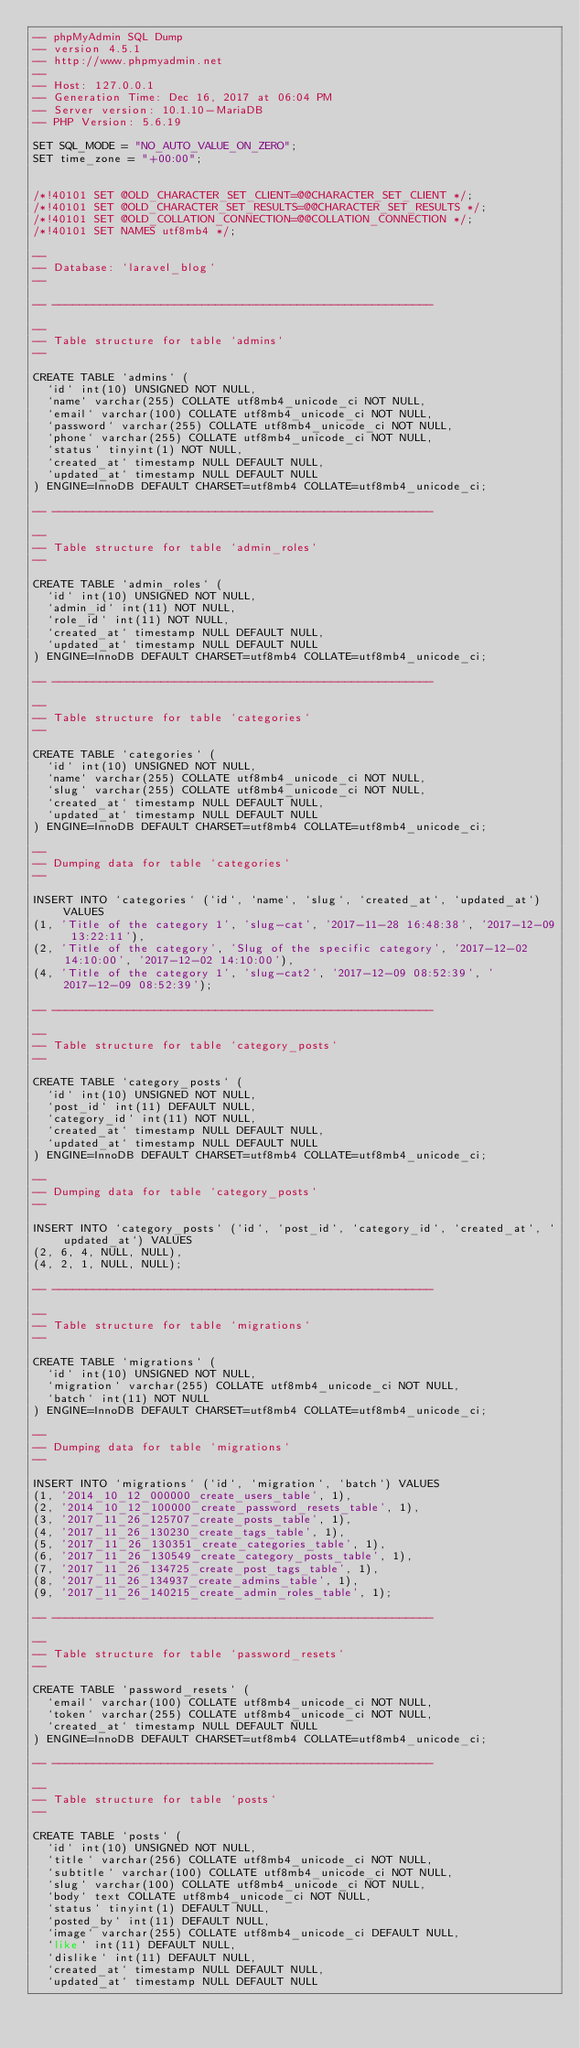<code> <loc_0><loc_0><loc_500><loc_500><_SQL_>-- phpMyAdmin SQL Dump
-- version 4.5.1
-- http://www.phpmyadmin.net
--
-- Host: 127.0.0.1
-- Generation Time: Dec 16, 2017 at 06:04 PM
-- Server version: 10.1.10-MariaDB
-- PHP Version: 5.6.19

SET SQL_MODE = "NO_AUTO_VALUE_ON_ZERO";
SET time_zone = "+00:00";


/*!40101 SET @OLD_CHARACTER_SET_CLIENT=@@CHARACTER_SET_CLIENT */;
/*!40101 SET @OLD_CHARACTER_SET_RESULTS=@@CHARACTER_SET_RESULTS */;
/*!40101 SET @OLD_COLLATION_CONNECTION=@@COLLATION_CONNECTION */;
/*!40101 SET NAMES utf8mb4 */;

--
-- Database: `laravel_blog`
--

-- --------------------------------------------------------

--
-- Table structure for table `admins`
--

CREATE TABLE `admins` (
  `id` int(10) UNSIGNED NOT NULL,
  `name` varchar(255) COLLATE utf8mb4_unicode_ci NOT NULL,
  `email` varchar(100) COLLATE utf8mb4_unicode_ci NOT NULL,
  `password` varchar(255) COLLATE utf8mb4_unicode_ci NOT NULL,
  `phone` varchar(255) COLLATE utf8mb4_unicode_ci NOT NULL,
  `status` tinyint(1) NOT NULL,
  `created_at` timestamp NULL DEFAULT NULL,
  `updated_at` timestamp NULL DEFAULT NULL
) ENGINE=InnoDB DEFAULT CHARSET=utf8mb4 COLLATE=utf8mb4_unicode_ci;

-- --------------------------------------------------------

--
-- Table structure for table `admin_roles`
--

CREATE TABLE `admin_roles` (
  `id` int(10) UNSIGNED NOT NULL,
  `admin_id` int(11) NOT NULL,
  `role_id` int(11) NOT NULL,
  `created_at` timestamp NULL DEFAULT NULL,
  `updated_at` timestamp NULL DEFAULT NULL
) ENGINE=InnoDB DEFAULT CHARSET=utf8mb4 COLLATE=utf8mb4_unicode_ci;

-- --------------------------------------------------------

--
-- Table structure for table `categories`
--

CREATE TABLE `categories` (
  `id` int(10) UNSIGNED NOT NULL,
  `name` varchar(255) COLLATE utf8mb4_unicode_ci NOT NULL,
  `slug` varchar(255) COLLATE utf8mb4_unicode_ci NOT NULL,
  `created_at` timestamp NULL DEFAULT NULL,
  `updated_at` timestamp NULL DEFAULT NULL
) ENGINE=InnoDB DEFAULT CHARSET=utf8mb4 COLLATE=utf8mb4_unicode_ci;

--
-- Dumping data for table `categories`
--

INSERT INTO `categories` (`id`, `name`, `slug`, `created_at`, `updated_at`) VALUES
(1, 'Title of the category 1', 'slug-cat', '2017-11-28 16:48:38', '2017-12-09 13:22:11'),
(2, 'Title of the category', 'Slug of the specific category', '2017-12-02 14:10:00', '2017-12-02 14:10:00'),
(4, 'Title of the category 1', 'slug-cat2', '2017-12-09 08:52:39', '2017-12-09 08:52:39');

-- --------------------------------------------------------

--
-- Table structure for table `category_posts`
--

CREATE TABLE `category_posts` (
  `id` int(10) UNSIGNED NOT NULL,
  `post_id` int(11) DEFAULT NULL,
  `category_id` int(11) NOT NULL,
  `created_at` timestamp NULL DEFAULT NULL,
  `updated_at` timestamp NULL DEFAULT NULL
) ENGINE=InnoDB DEFAULT CHARSET=utf8mb4 COLLATE=utf8mb4_unicode_ci;

--
-- Dumping data for table `category_posts`
--

INSERT INTO `category_posts` (`id`, `post_id`, `category_id`, `created_at`, `updated_at`) VALUES
(2, 6, 4, NULL, NULL),
(4, 2, 1, NULL, NULL);

-- --------------------------------------------------------

--
-- Table structure for table `migrations`
--

CREATE TABLE `migrations` (
  `id` int(10) UNSIGNED NOT NULL,
  `migration` varchar(255) COLLATE utf8mb4_unicode_ci NOT NULL,
  `batch` int(11) NOT NULL
) ENGINE=InnoDB DEFAULT CHARSET=utf8mb4 COLLATE=utf8mb4_unicode_ci;

--
-- Dumping data for table `migrations`
--

INSERT INTO `migrations` (`id`, `migration`, `batch`) VALUES
(1, '2014_10_12_000000_create_users_table', 1),
(2, '2014_10_12_100000_create_password_resets_table', 1),
(3, '2017_11_26_125707_create_posts_table', 1),
(4, '2017_11_26_130230_create_tags_table', 1),
(5, '2017_11_26_130351_create_categories_table', 1),
(6, '2017_11_26_130549_create_category_posts_table', 1),
(7, '2017_11_26_134725_create_post_tags_table', 1),
(8, '2017_11_26_134937_create_admins_table', 1),
(9, '2017_11_26_140215_create_admin_roles_table', 1);

-- --------------------------------------------------------

--
-- Table structure for table `password_resets`
--

CREATE TABLE `password_resets` (
  `email` varchar(100) COLLATE utf8mb4_unicode_ci NOT NULL,
  `token` varchar(255) COLLATE utf8mb4_unicode_ci NOT NULL,
  `created_at` timestamp NULL DEFAULT NULL
) ENGINE=InnoDB DEFAULT CHARSET=utf8mb4 COLLATE=utf8mb4_unicode_ci;

-- --------------------------------------------------------

--
-- Table structure for table `posts`
--

CREATE TABLE `posts` (
  `id` int(10) UNSIGNED NOT NULL,
  `title` varchar(256) COLLATE utf8mb4_unicode_ci NOT NULL,
  `subtitle` varchar(100) COLLATE utf8mb4_unicode_ci NOT NULL,
  `slug` varchar(100) COLLATE utf8mb4_unicode_ci NOT NULL,
  `body` text COLLATE utf8mb4_unicode_ci NOT NULL,
  `status` tinyint(1) DEFAULT NULL,
  `posted_by` int(11) DEFAULT NULL,
  `image` varchar(255) COLLATE utf8mb4_unicode_ci DEFAULT NULL,
  `like` int(11) DEFAULT NULL,
  `dislike` int(11) DEFAULT NULL,
  `created_at` timestamp NULL DEFAULT NULL,
  `updated_at` timestamp NULL DEFAULT NULL</code> 